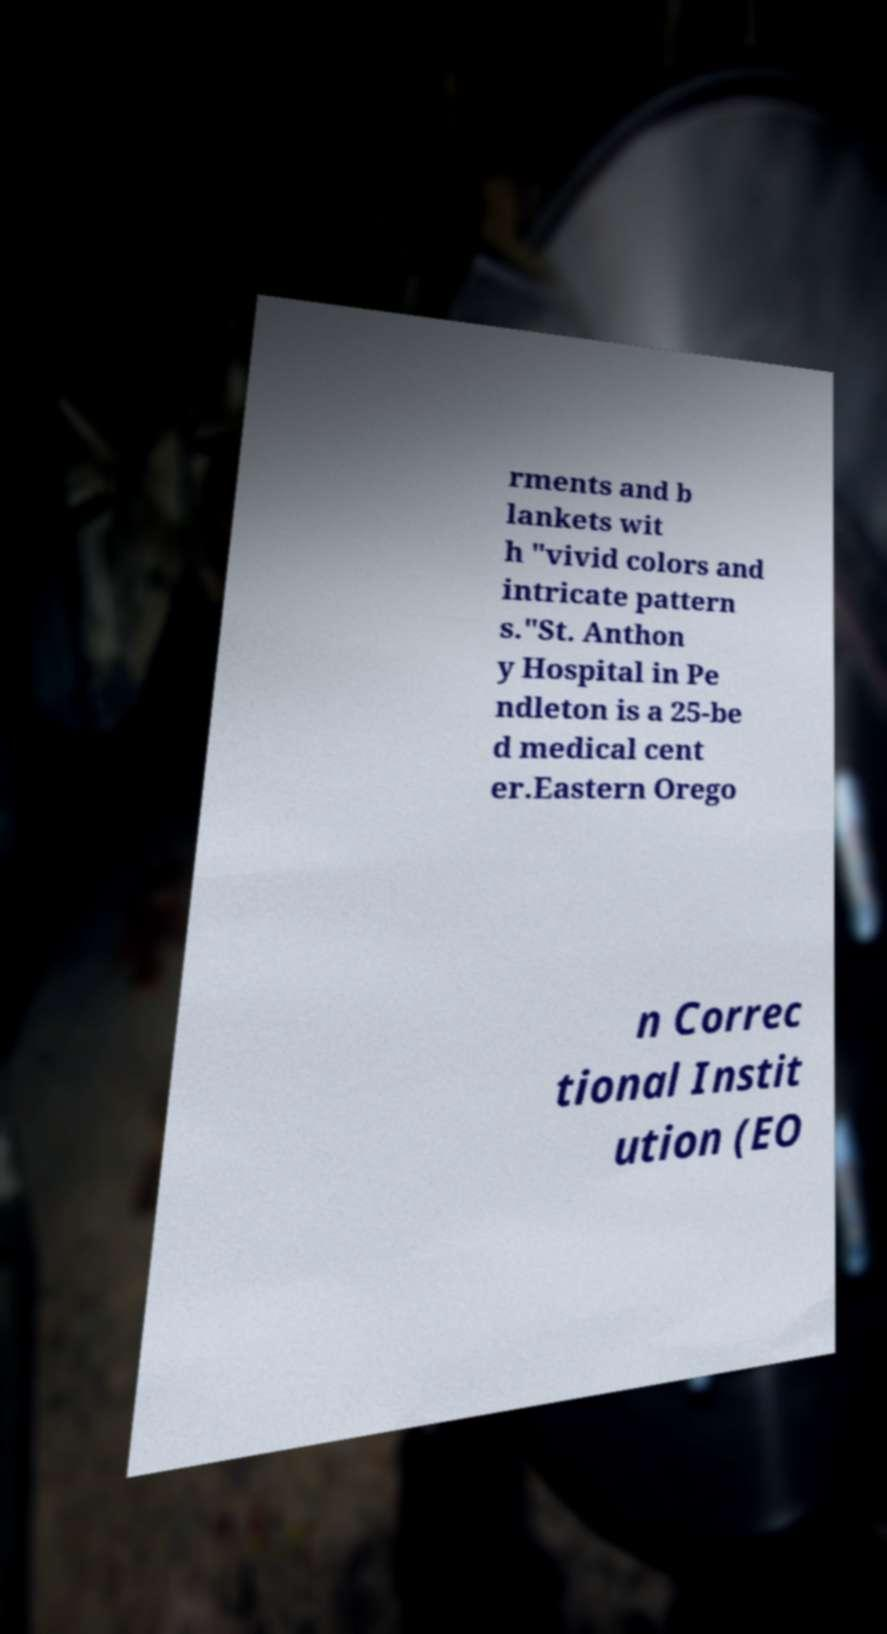Could you assist in decoding the text presented in this image and type it out clearly? rments and b lankets wit h "vivid colors and intricate pattern s."St. Anthon y Hospital in Pe ndleton is a 25-be d medical cent er.Eastern Orego n Correc tional Instit ution (EO 